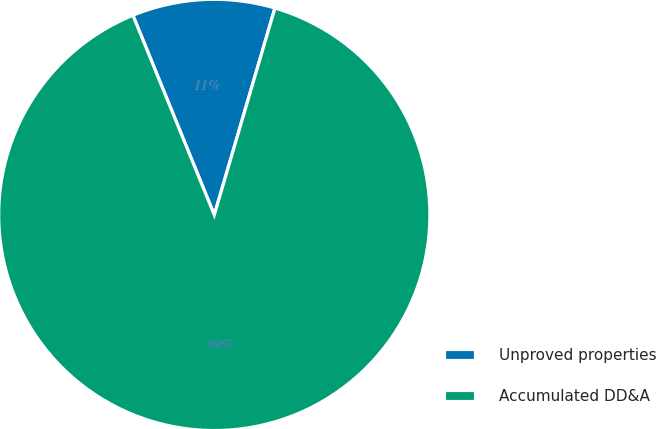Convert chart to OTSL. <chart><loc_0><loc_0><loc_500><loc_500><pie_chart><fcel>Unproved properties<fcel>Accumulated DD&A<nl><fcel>10.7%<fcel>89.3%<nl></chart> 